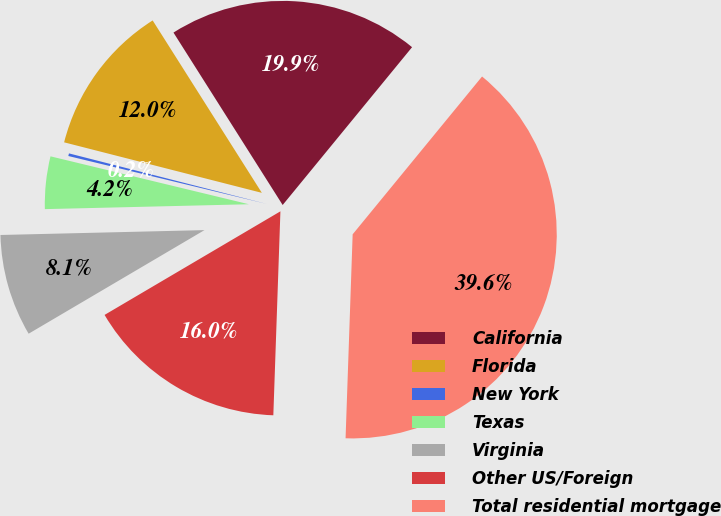Convert chart to OTSL. <chart><loc_0><loc_0><loc_500><loc_500><pie_chart><fcel>California<fcel>Florida<fcel>New York<fcel>Texas<fcel>Virginia<fcel>Other US/Foreign<fcel>Total residential mortgage<nl><fcel>19.91%<fcel>12.03%<fcel>0.21%<fcel>4.15%<fcel>8.09%<fcel>15.97%<fcel>39.61%<nl></chart> 